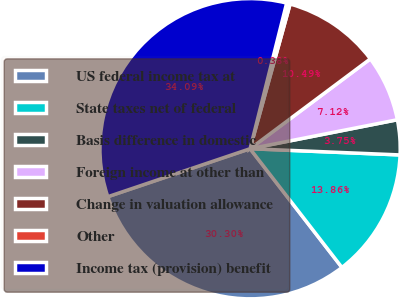Convert chart. <chart><loc_0><loc_0><loc_500><loc_500><pie_chart><fcel>US federal income tax at<fcel>State taxes net of federal<fcel>Basis difference in domestic<fcel>Foreign income at other than<fcel>Change in valuation allowance<fcel>Other<fcel>Income tax (provision) benefit<nl><fcel>30.3%<fcel>13.86%<fcel>3.75%<fcel>7.12%<fcel>10.49%<fcel>0.38%<fcel>34.09%<nl></chart> 